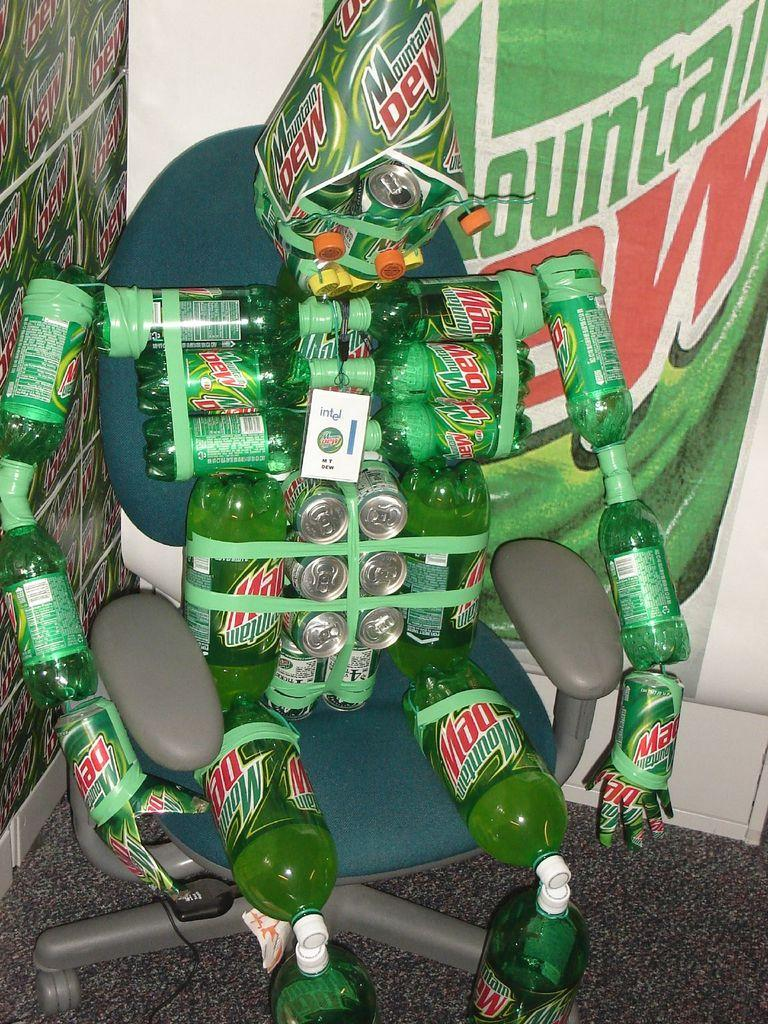What is the main object in the image made of? The main object in the image is a toy made with bottles and tins. Where is the toy located in the image? The toy is sitting on a chair in the image. What type of surface is visible in the image? The image shows a floor. What can be seen in the background of the image? There are hoardings visible in the background of the image. What type of rifle is being used by the family member in the image? There is no rifle or family member present in the image; it features a toy made with bottles and tins sitting on a chair. 